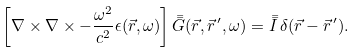Convert formula to latex. <formula><loc_0><loc_0><loc_500><loc_500>\left [ \nabla \times \nabla \times - \frac { \omega ^ { 2 } } { c ^ { 2 } } \epsilon ( \vec { r } , \omega ) \right ] \bar { \bar { G } } ( \vec { r } , \vec { r } ^ { \, \prime } , \omega ) = \bar { \bar { I } } \, \delta ( \vec { r } - \vec { r } ^ { \, \prime } ) .</formula> 